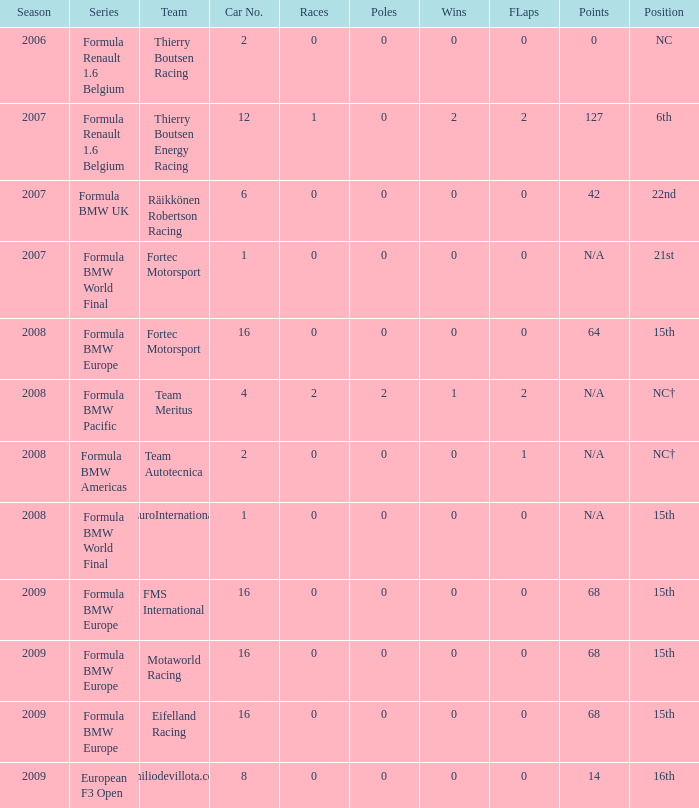Name the position for eifelland racing 15th. Help me parse the entirety of this table. {'header': ['Season', 'Series', 'Team', 'Car No.', 'Races', 'Poles', 'Wins', 'FLaps', 'Points', 'Position'], 'rows': [['2006', 'Formula Renault 1.6 Belgium', 'Thierry Boutsen Racing', '2', '0', '0', '0', '0', '0', 'NC'], ['2007', 'Formula Renault 1.6 Belgium', 'Thierry Boutsen Energy Racing', '12', '1', '0', '2', '2', '127', '6th'], ['2007', 'Formula BMW UK', 'Räikkönen Robertson Racing', '6', '0', '0', '0', '0', '42', '22nd'], ['2007', 'Formula BMW World Final', 'Fortec Motorsport', '1', '0', '0', '0', '0', 'N/A', '21st'], ['2008', 'Formula BMW Europe', 'Fortec Motorsport', '16', '0', '0', '0', '0', '64', '15th'], ['2008', 'Formula BMW Pacific', 'Team Meritus', '4', '2', '2', '1', '2', 'N/A', 'NC†'], ['2008', 'Formula BMW Americas', 'Team Autotecnica', '2', '0', '0', '0', '1', 'N/A', 'NC†'], ['2008', 'Formula BMW World Final', 'EuroInternational', '1', '0', '0', '0', '0', 'N/A', '15th'], ['2009', 'Formula BMW Europe', 'FMS International', '16', '0', '0', '0', '0', '68', '15th'], ['2009', 'Formula BMW Europe', 'Motaworld Racing', '16', '0', '0', '0', '0', '68', '15th'], ['2009', 'Formula BMW Europe', 'Eifelland Racing', '16', '0', '0', '0', '0', '68', '15th'], ['2009', 'European F3 Open', 'Emiliodevillota.com', '8', '0', '0', '0', '0', '14', '16th']]} 